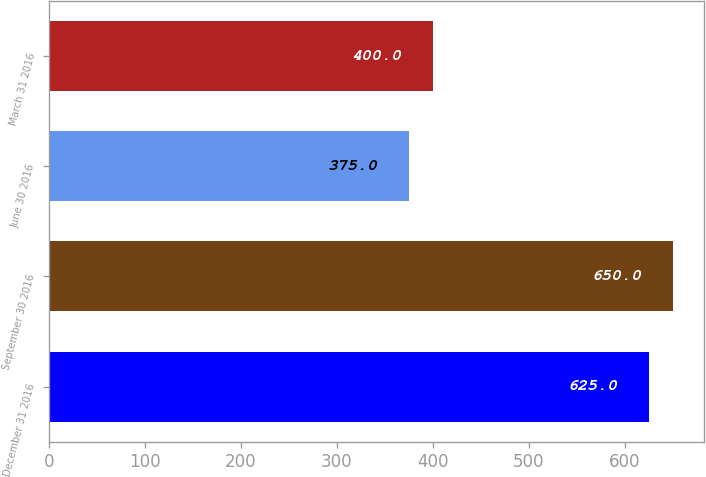<chart> <loc_0><loc_0><loc_500><loc_500><bar_chart><fcel>December 31 2016<fcel>September 30 2016<fcel>June 30 2016<fcel>March 31 2016<nl><fcel>625<fcel>650<fcel>375<fcel>400<nl></chart> 